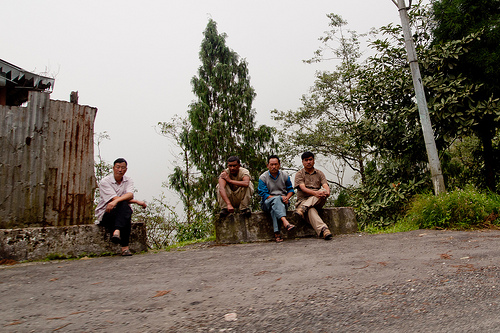<image>
Is the man to the left of the man? Yes. From this viewpoint, the man is positioned to the left side relative to the man. Where is the tree in relation to the man? Is it to the left of the man? No. The tree is not to the left of the man. From this viewpoint, they have a different horizontal relationship. 